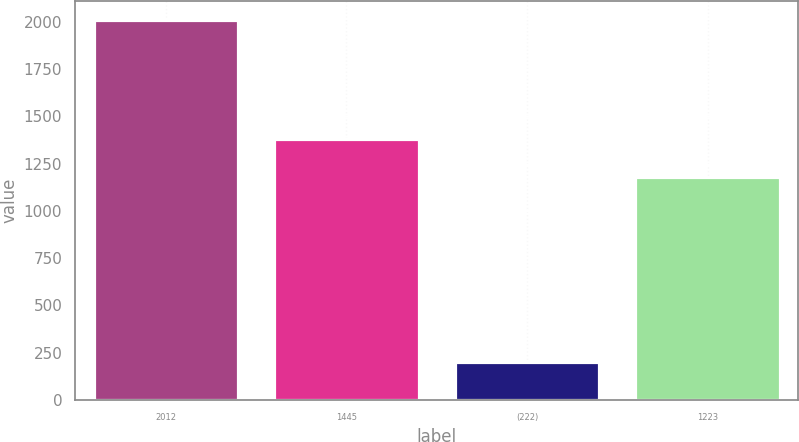Convert chart. <chart><loc_0><loc_0><loc_500><loc_500><bar_chart><fcel>2012<fcel>1445<fcel>(222)<fcel>1223<nl><fcel>2010<fcel>1382<fcel>203<fcel>1179<nl></chart> 